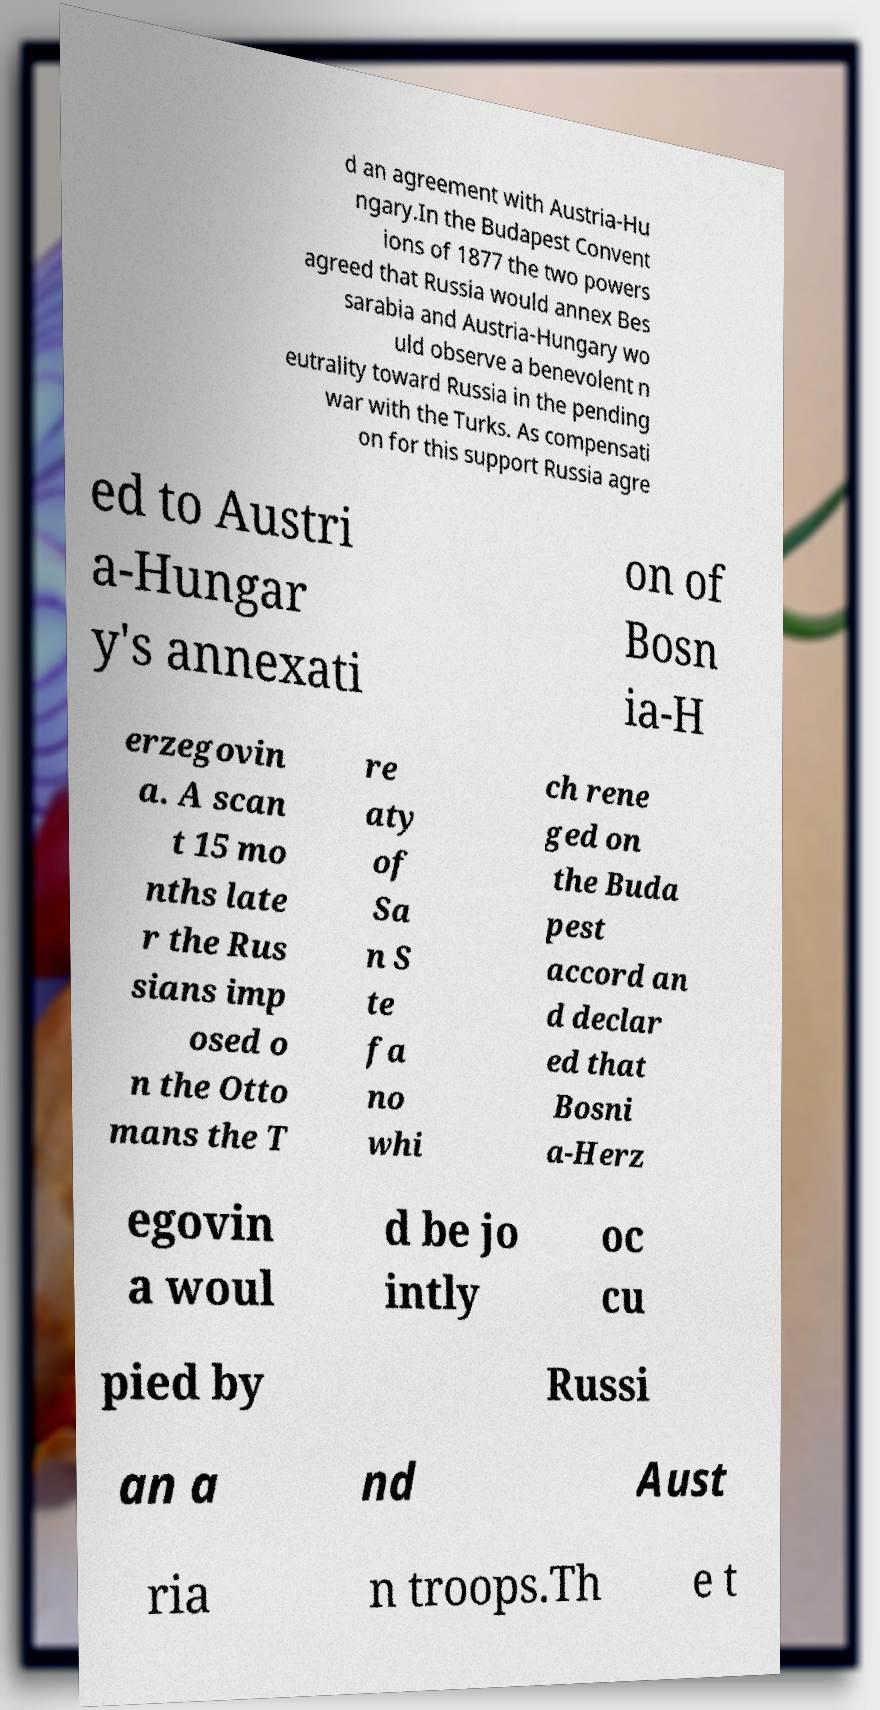I need the written content from this picture converted into text. Can you do that? d an agreement with Austria-Hu ngary.In the Budapest Convent ions of 1877 the two powers agreed that Russia would annex Bes sarabia and Austria-Hungary wo uld observe a benevolent n eutrality toward Russia in the pending war with the Turks. As compensati on for this support Russia agre ed to Austri a-Hungar y's annexati on of Bosn ia-H erzegovin a. A scan t 15 mo nths late r the Rus sians imp osed o n the Otto mans the T re aty of Sa n S te fa no whi ch rene ged on the Buda pest accord an d declar ed that Bosni a-Herz egovin a woul d be jo intly oc cu pied by Russi an a nd Aust ria n troops.Th e t 